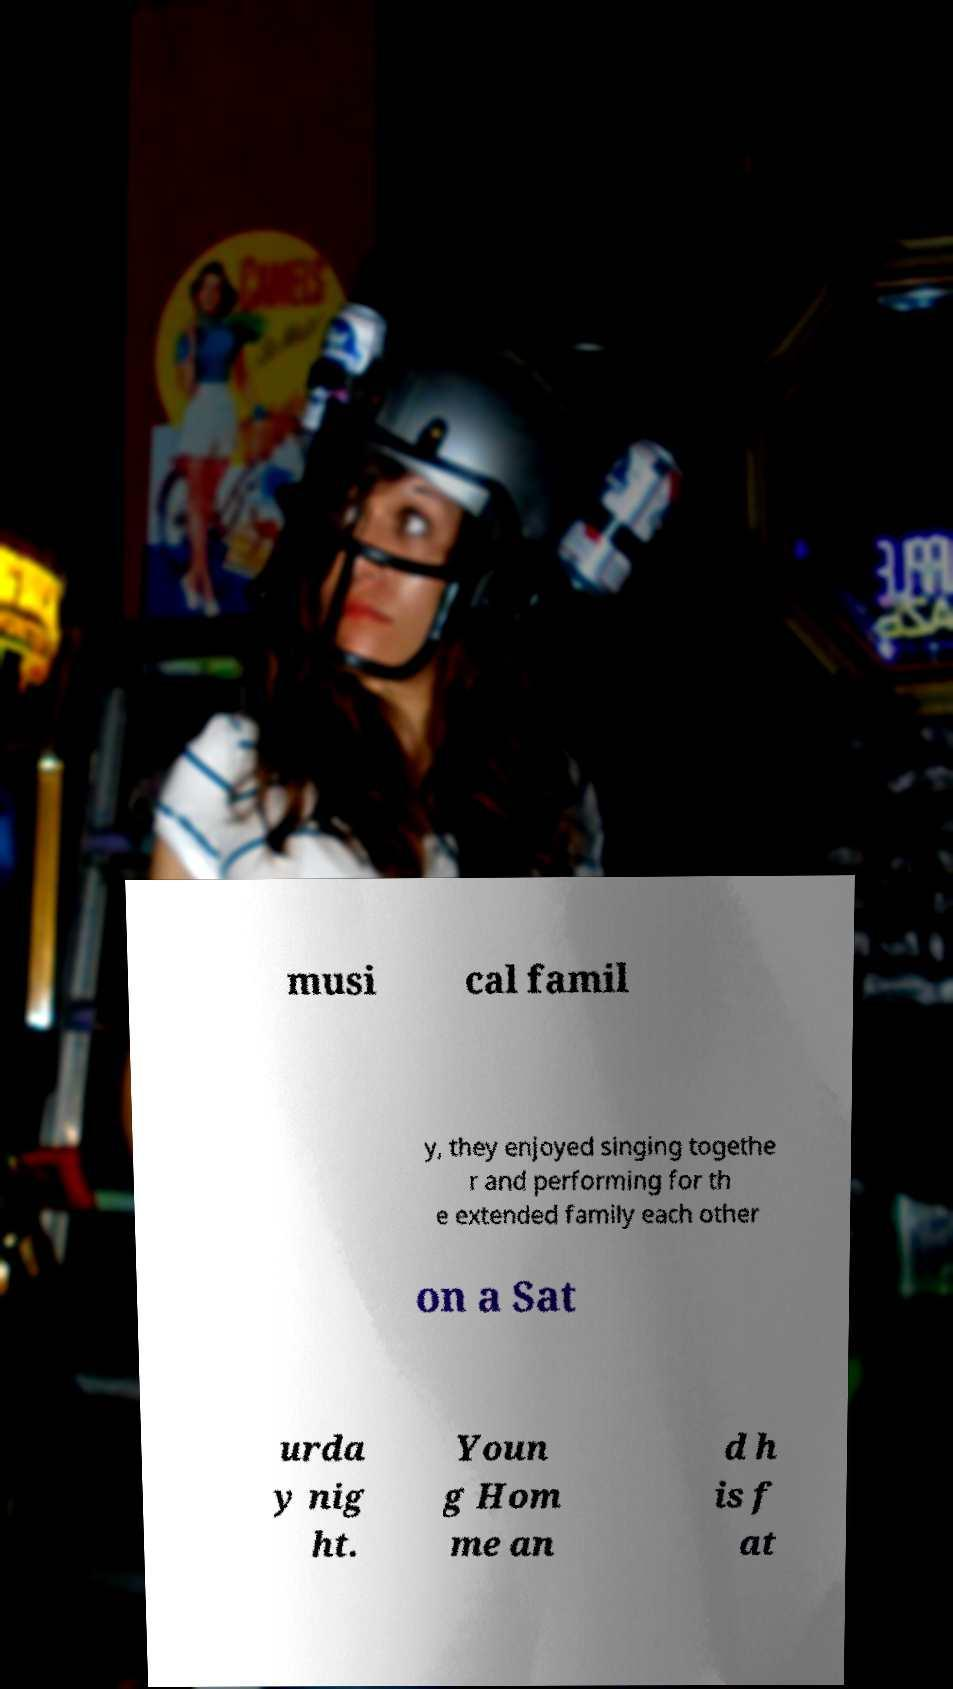Can you read and provide the text displayed in the image?This photo seems to have some interesting text. Can you extract and type it out for me? musi cal famil y, they enjoyed singing togethe r and performing for th e extended family each other on a Sat urda y nig ht. Youn g Hom me an d h is f at 